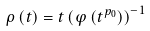Convert formula to latex. <formula><loc_0><loc_0><loc_500><loc_500>\rho \left ( t \right ) = t \left ( \varphi \left ( t ^ { p _ { 0 } } \right ) \right ) ^ { - 1 }</formula> 